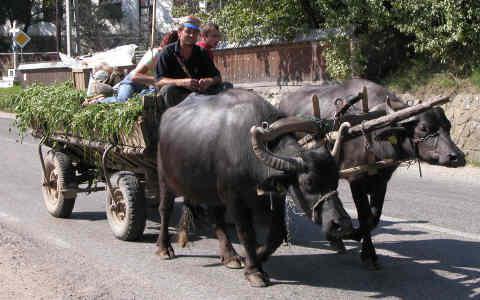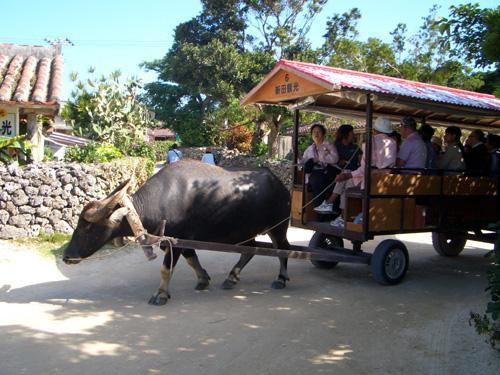The first image is the image on the left, the second image is the image on the right. Considering the images on both sides, is "A single cow is pulling the load in one of the images." valid? Answer yes or no. Yes. The first image is the image on the left, the second image is the image on the right. Assess this claim about the two images: "An image shows at least one person walking rightward with at least one ox that is not hitched to any wagon.". Correct or not? Answer yes or no. No. 